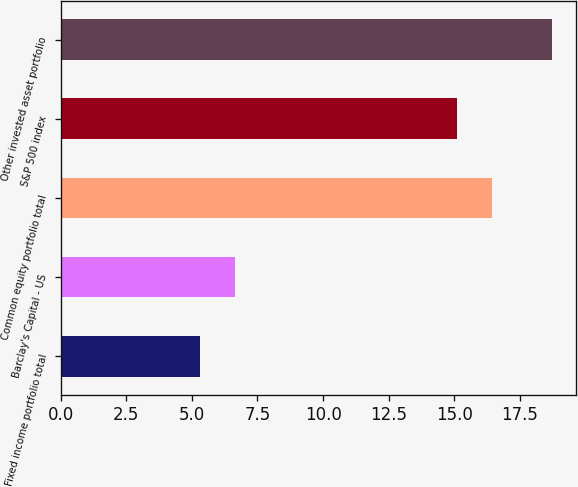Convert chart. <chart><loc_0><loc_0><loc_500><loc_500><bar_chart><fcel>Fixed income portfolio total<fcel>Barclay's Capital - US<fcel>Common equity portfolio total<fcel>S&P 500 index<fcel>Other invested asset portfolio<nl><fcel>5.3<fcel>6.64<fcel>16.44<fcel>15.1<fcel>18.7<nl></chart> 